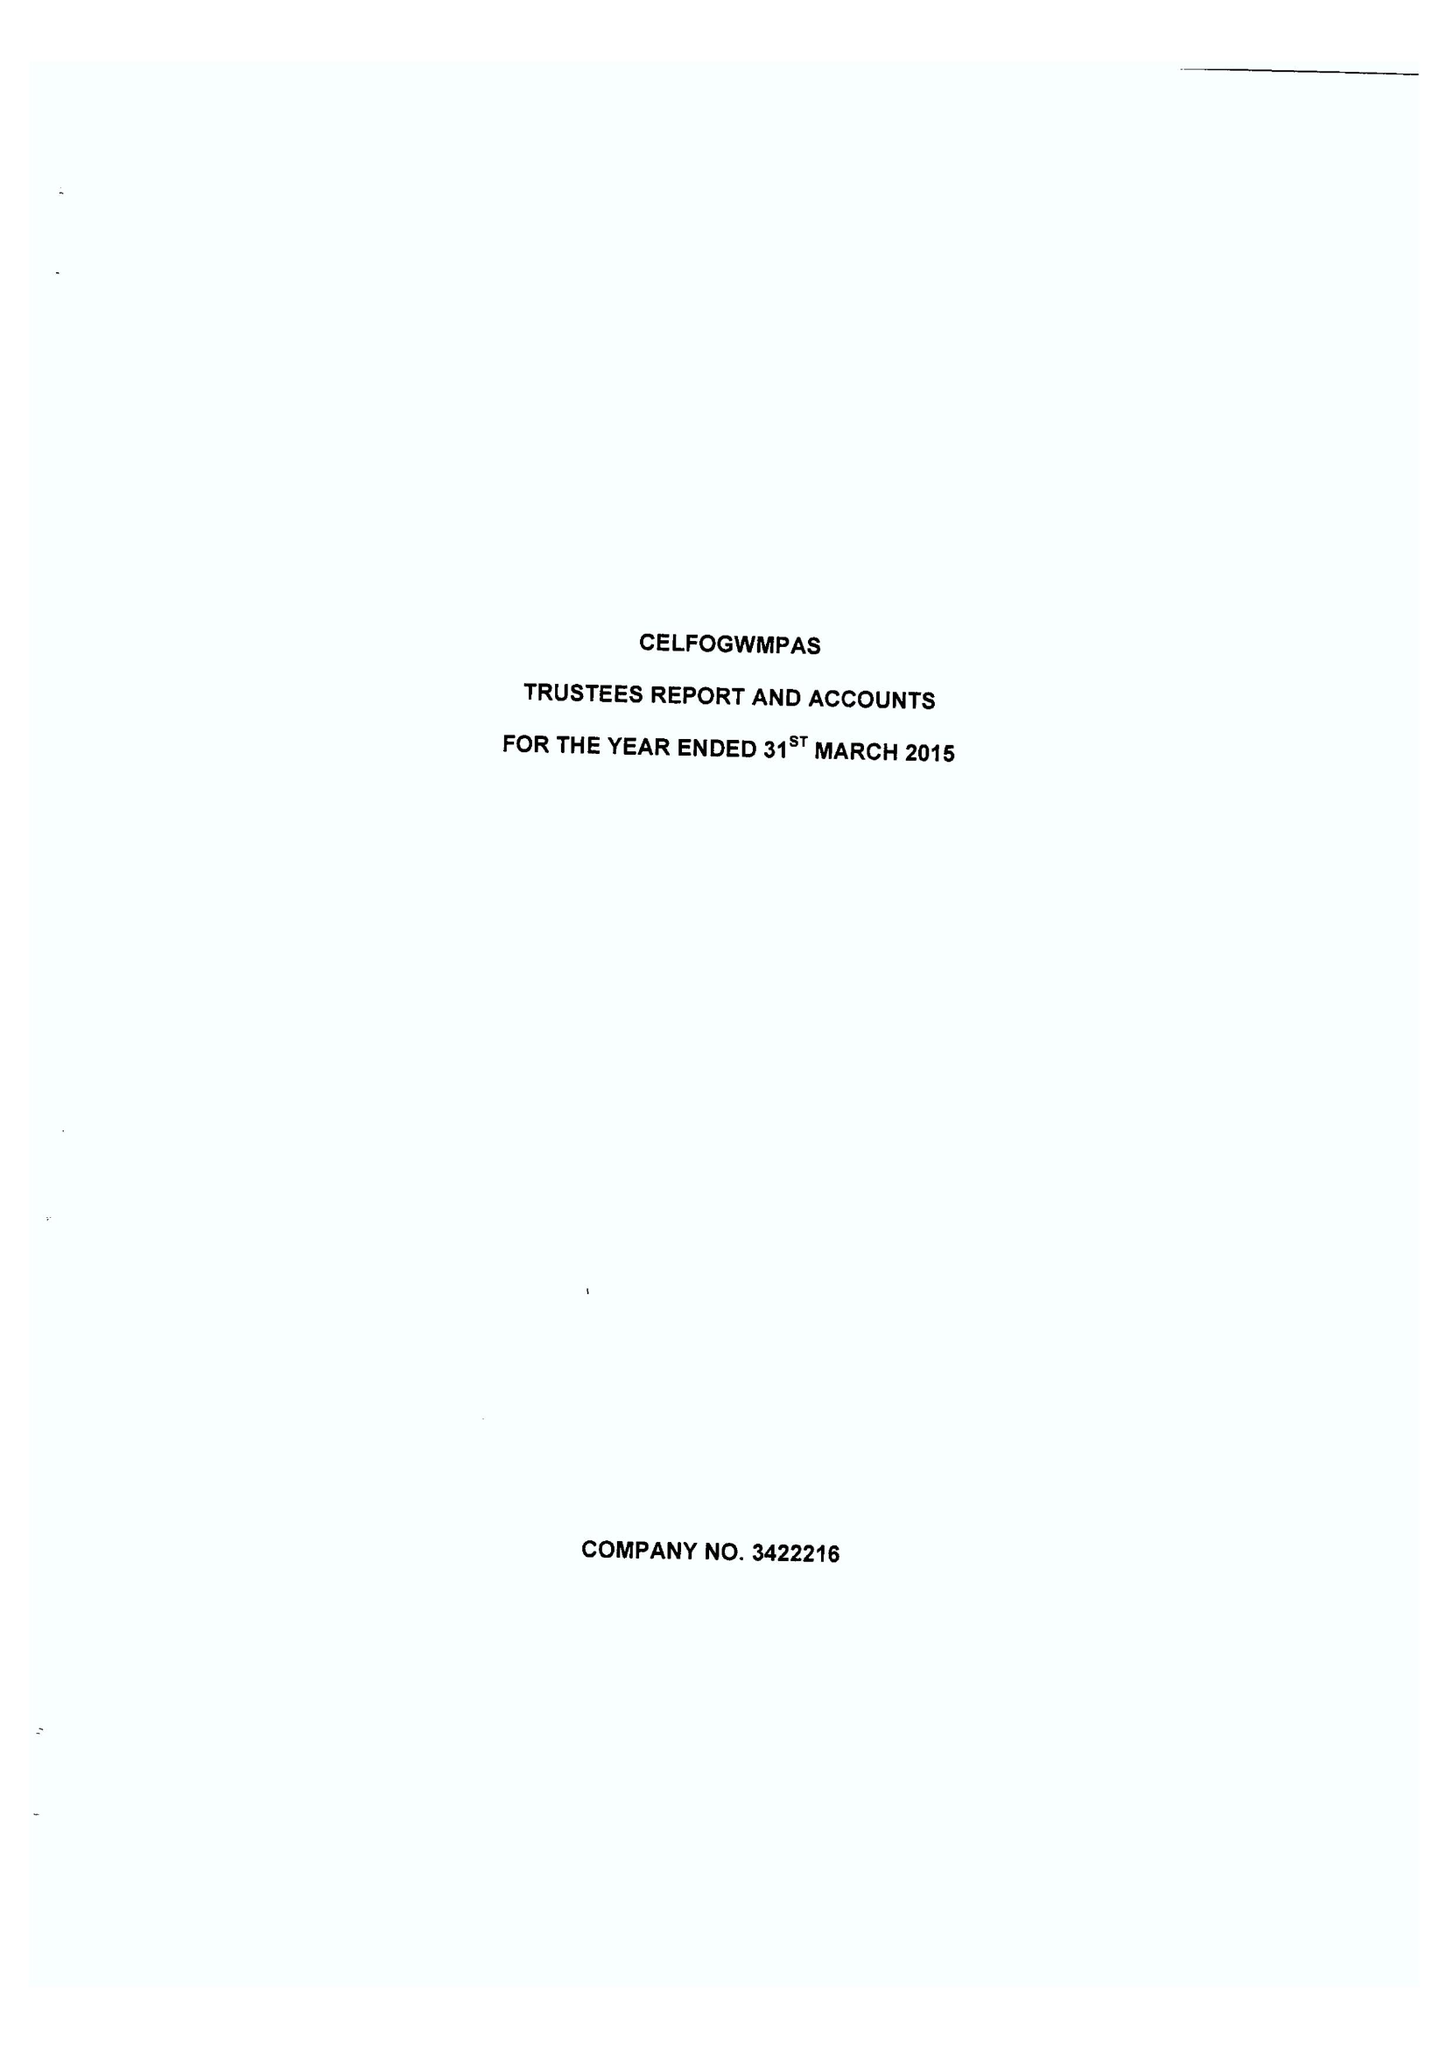What is the value for the report_date?
Answer the question using a single word or phrase. 2015-03-31 